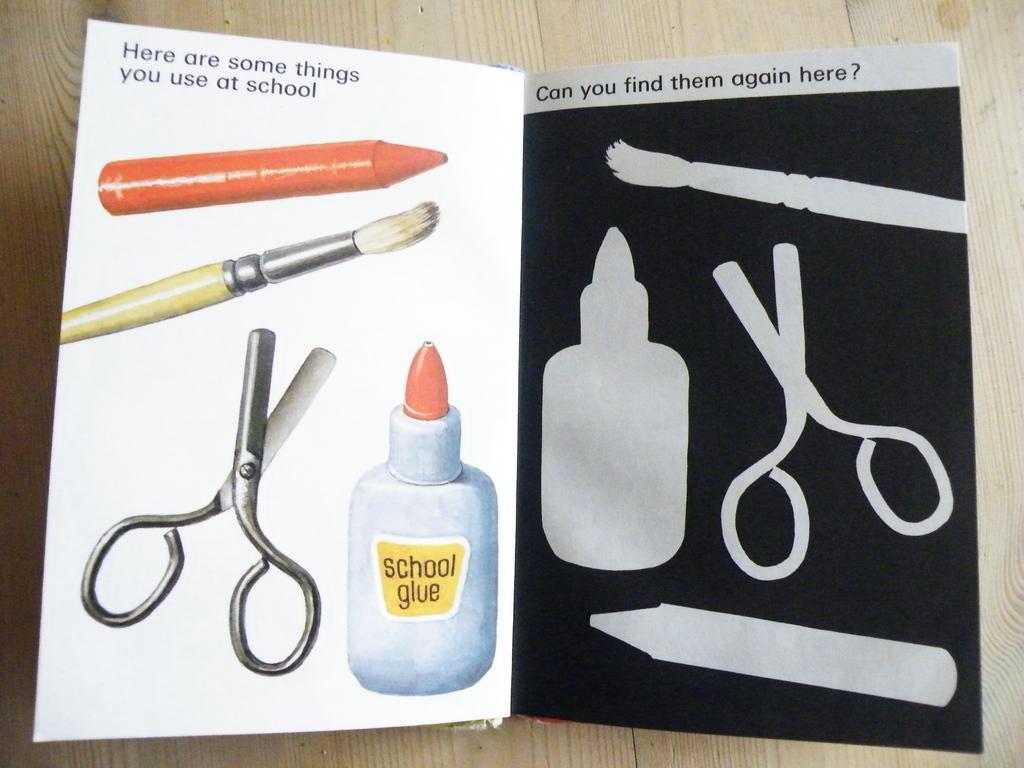Please provide a concise description of this image. In this picture we can see a craft book placed on the wooden table. In the front we can see scissor, bottle, brush and crayon in the book. 